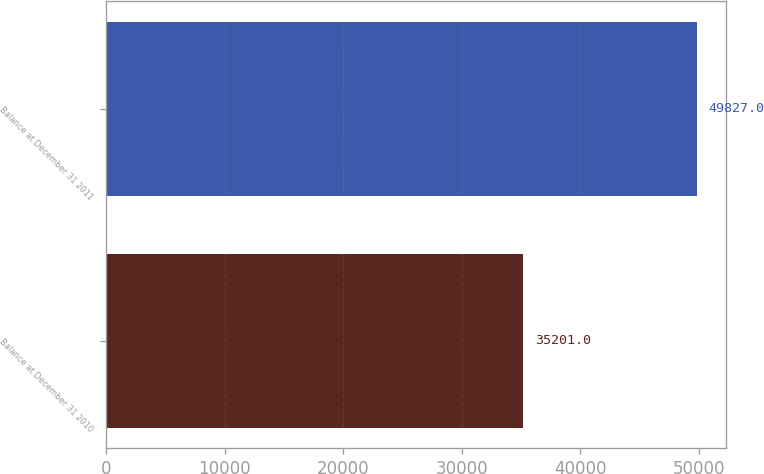Convert chart to OTSL. <chart><loc_0><loc_0><loc_500><loc_500><bar_chart><fcel>Balance at December 31 2010<fcel>Balance at December 31 2011<nl><fcel>35201<fcel>49827<nl></chart> 